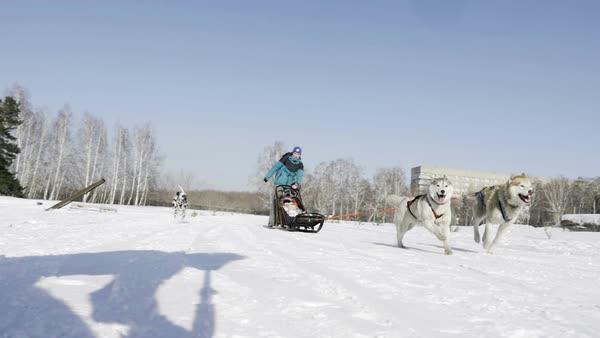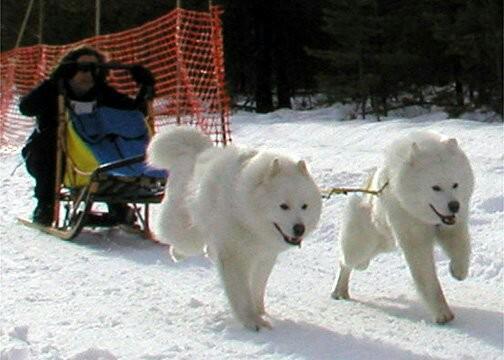The first image is the image on the left, the second image is the image on the right. Analyze the images presented: Is the assertion "There are no more than three sledding dogs in the right image." valid? Answer yes or no. Yes. The first image is the image on the left, the second image is the image on the right. Assess this claim about the two images: "There are at least three people in the sled in one of the images.". Correct or not? Answer yes or no. No. 